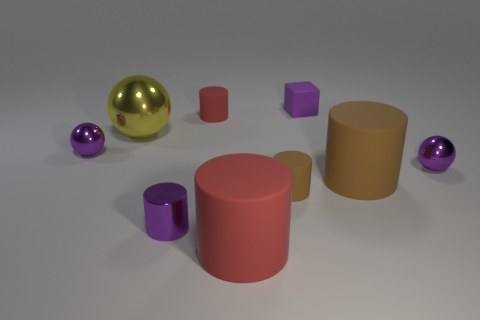Subtract 2 cylinders. How many cylinders are left? 3 Subtract all yellow cylinders. Subtract all red spheres. How many cylinders are left? 5 Add 1 large matte objects. How many objects exist? 10 Subtract all cylinders. How many objects are left? 4 Add 7 purple metallic spheres. How many purple metallic spheres are left? 9 Add 1 small purple cylinders. How many small purple cylinders exist? 2 Subtract 1 purple cylinders. How many objects are left? 8 Subtract all matte objects. Subtract all tiny rubber blocks. How many objects are left? 3 